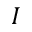Convert formula to latex. <formula><loc_0><loc_0><loc_500><loc_500>I</formula> 